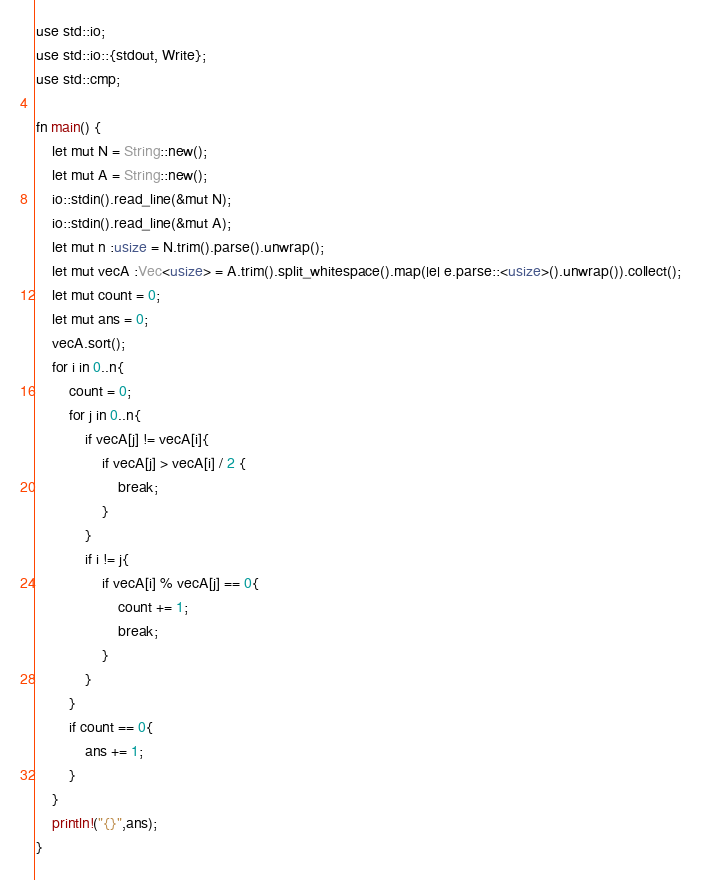<code> <loc_0><loc_0><loc_500><loc_500><_Rust_>use std::io;
use std::io::{stdout, Write};
use std::cmp;

fn main() {
    let mut N = String::new();
    let mut A = String::new();
    io::stdin().read_line(&mut N);
    io::stdin().read_line(&mut A);
    let mut n :usize = N.trim().parse().unwrap();
    let mut vecA :Vec<usize> = A.trim().split_whitespace().map(|e| e.parse::<usize>().unwrap()).collect();
    let mut count = 0;
    let mut ans = 0;
    vecA.sort();
    for i in 0..n{
        count = 0;
        for j in 0..n{
            if vecA[j] != vecA[i]{
                if vecA[j] > vecA[i] / 2 {
                    break;
                }
            }
            if i != j{
                if vecA[i] % vecA[j] == 0{
                    count += 1;
                    break;
                }
            }
        }
        if count == 0{
            ans += 1;
        }
    }
    println!("{}",ans);
}</code> 